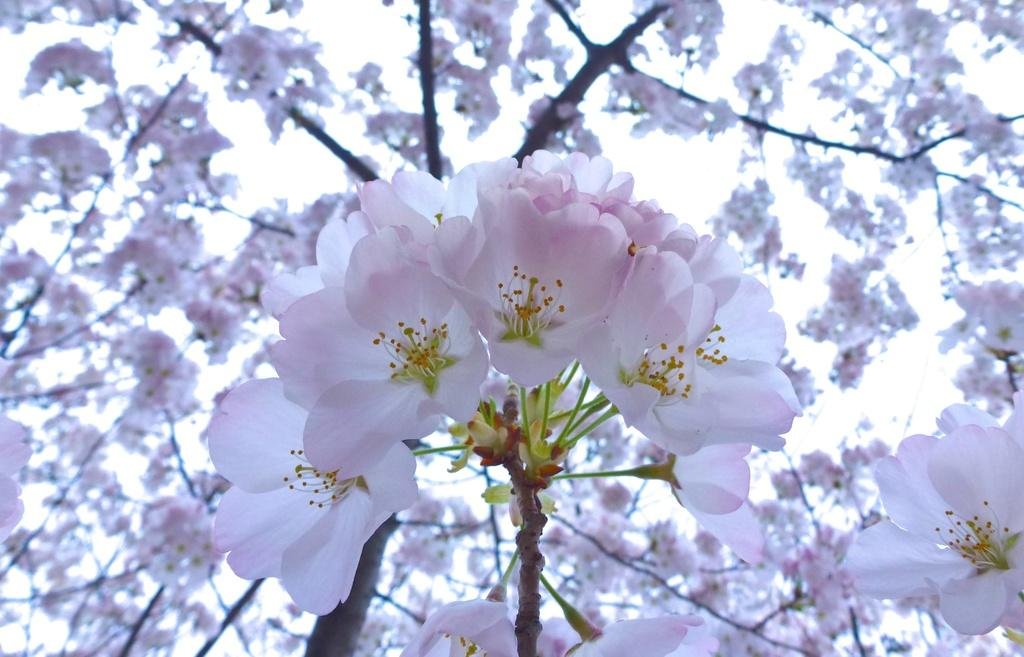What type of flora can be seen in the image? There are flowers in the image. What can be seen in the background of the image? There are trees and the sky visible in the background of the image. How many jellyfish are swimming in the image? There are no jellyfish present in the image; it features flowers, trees, and the sky. 